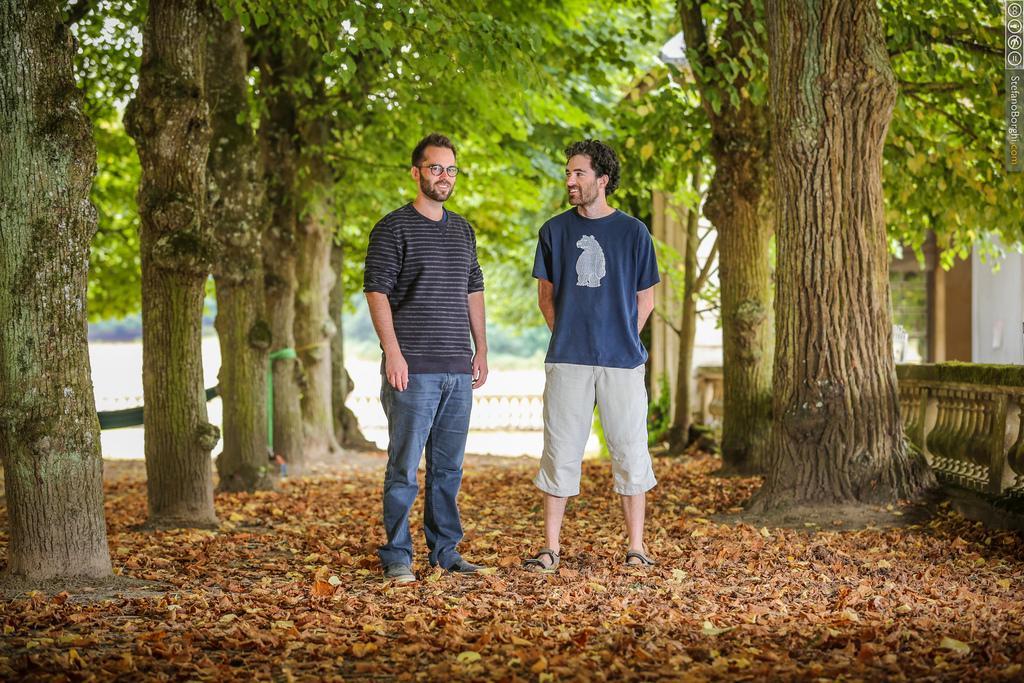Please provide a concise description of this image. This is an outside view. In the middle of the image there are two men standing and smiling. On the ground, I can see the dry leaves. On the right and left side of the image there are many trees. On the right side there is a railing and a building. 